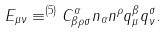<formula> <loc_0><loc_0><loc_500><loc_500>E _ { \mu \nu } \equiv ^ { ( 5 ) } C ^ { \alpha } _ { \beta \rho \sigma } n _ { \alpha } n ^ { \rho } q _ { \mu } ^ { \beta } q _ { \nu } ^ { \sigma } .</formula> 